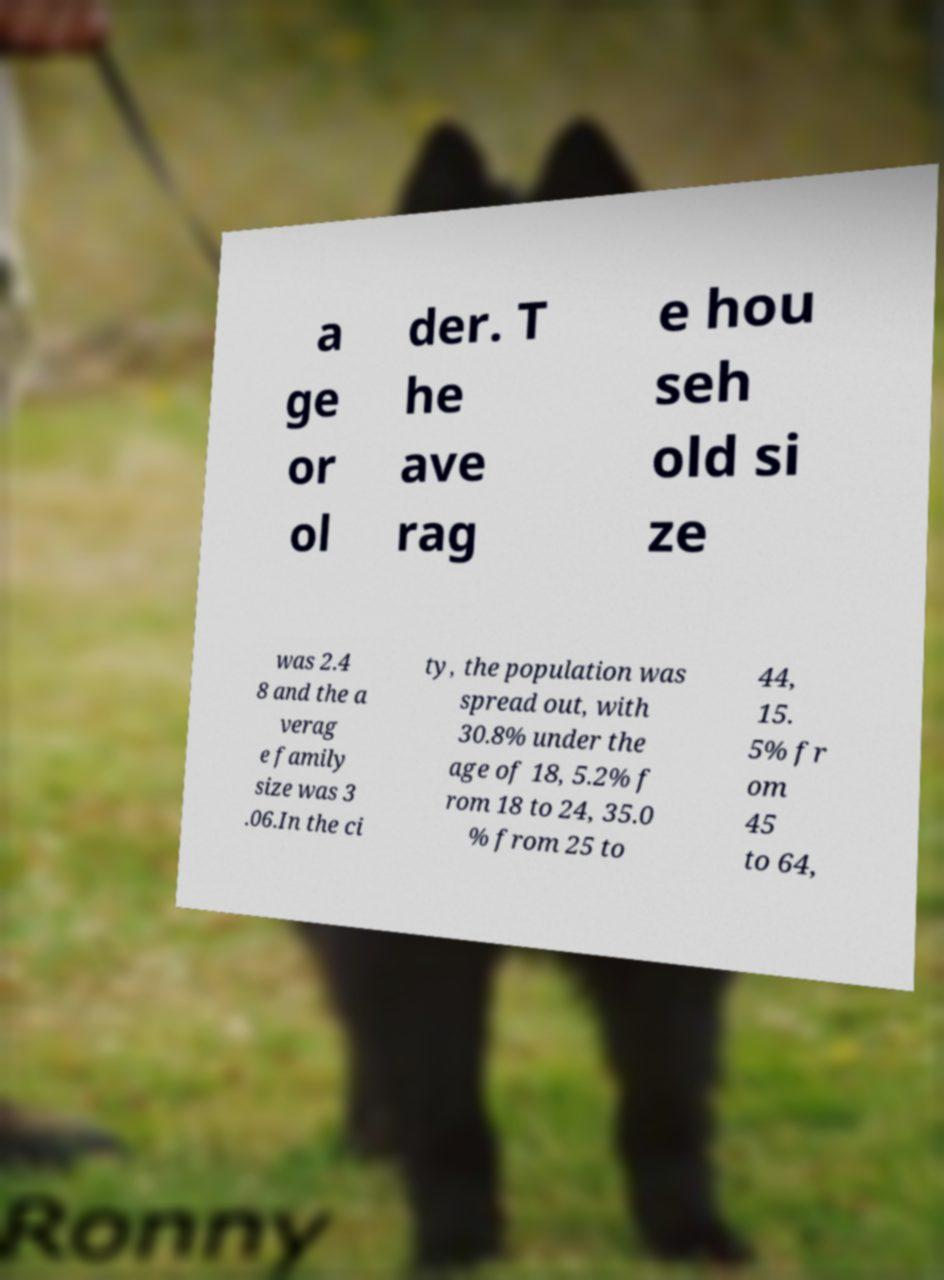Could you extract and type out the text from this image? a ge or ol der. T he ave rag e hou seh old si ze was 2.4 8 and the a verag e family size was 3 .06.In the ci ty, the population was spread out, with 30.8% under the age of 18, 5.2% f rom 18 to 24, 35.0 % from 25 to 44, 15. 5% fr om 45 to 64, 